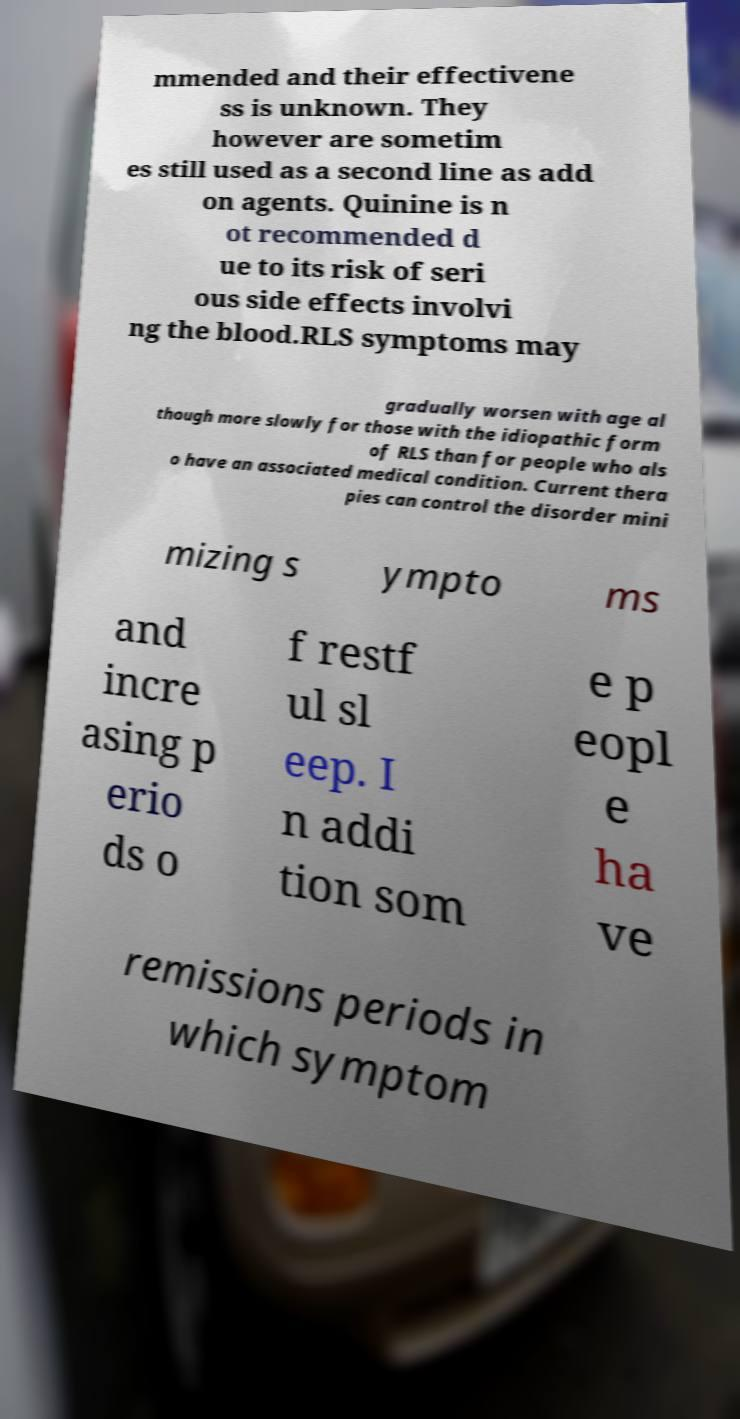I need the written content from this picture converted into text. Can you do that? mmended and their effectivene ss is unknown. They however are sometim es still used as a second line as add on agents. Quinine is n ot recommended d ue to its risk of seri ous side effects involvi ng the blood.RLS symptoms may gradually worsen with age al though more slowly for those with the idiopathic form of RLS than for people who als o have an associated medical condition. Current thera pies can control the disorder mini mizing s ympto ms and incre asing p erio ds o f restf ul sl eep. I n addi tion som e p eopl e ha ve remissions periods in which symptom 